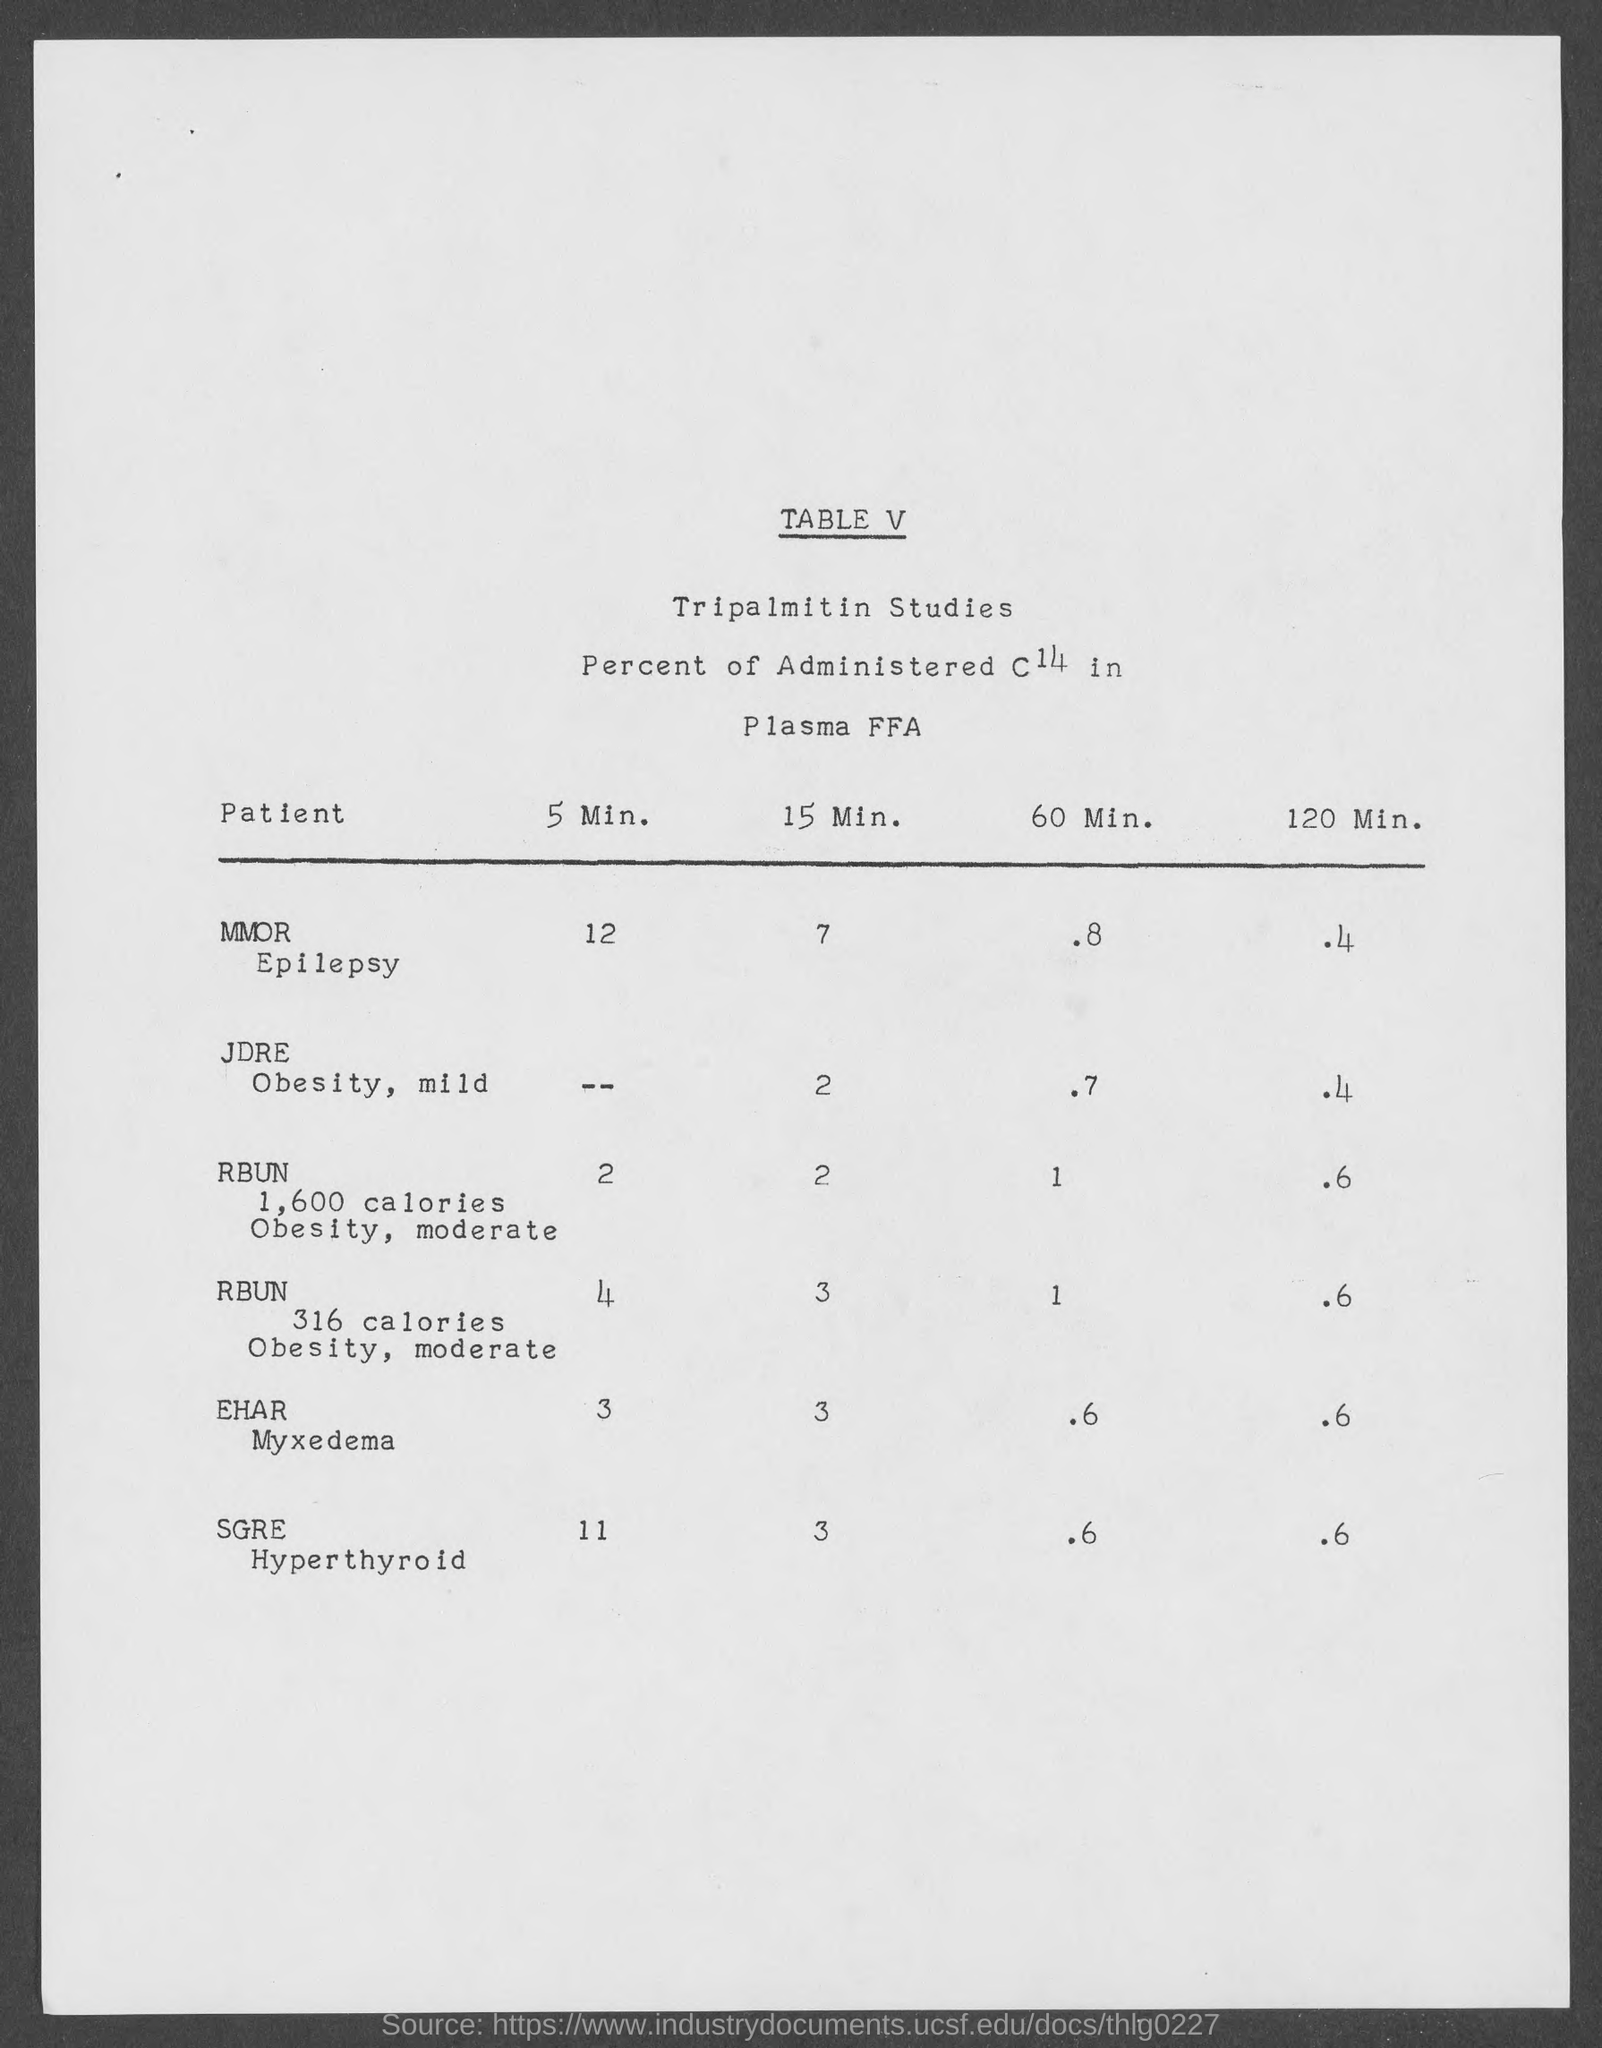What is the table no.?
Your response must be concise. V. 